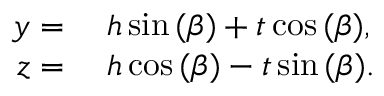<formula> <loc_0><loc_0><loc_500><loc_500>\begin{array} { r l } { y } & h \sin { ( \beta ) } + t \cos { ( \beta ) } , } \\ { z } & h \cos { ( \beta ) } - t \sin { ( \beta ) } . } \end{array}</formula> 